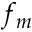<formula> <loc_0><loc_0><loc_500><loc_500>f _ { m }</formula> 